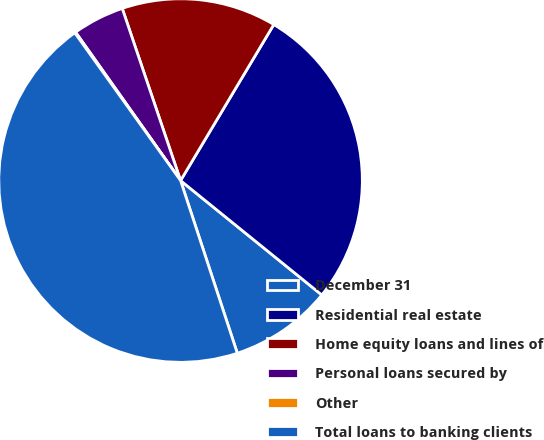Convert chart to OTSL. <chart><loc_0><loc_0><loc_500><loc_500><pie_chart><fcel>December 31<fcel>Residential real estate<fcel>Home equity loans and lines of<fcel>Personal loans secured by<fcel>Other<fcel>Total loans to banking clients<nl><fcel>9.11%<fcel>27.26%<fcel>13.77%<fcel>4.6%<fcel>0.09%<fcel>45.16%<nl></chart> 